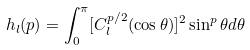Convert formula to latex. <formula><loc_0><loc_0><loc_500><loc_500>h _ { l } ( p ) = \int _ { 0 } ^ { \pi } [ C _ { l } ^ { p / 2 } ( \cos \theta ) ] ^ { 2 } \sin ^ { p } \theta d \theta</formula> 